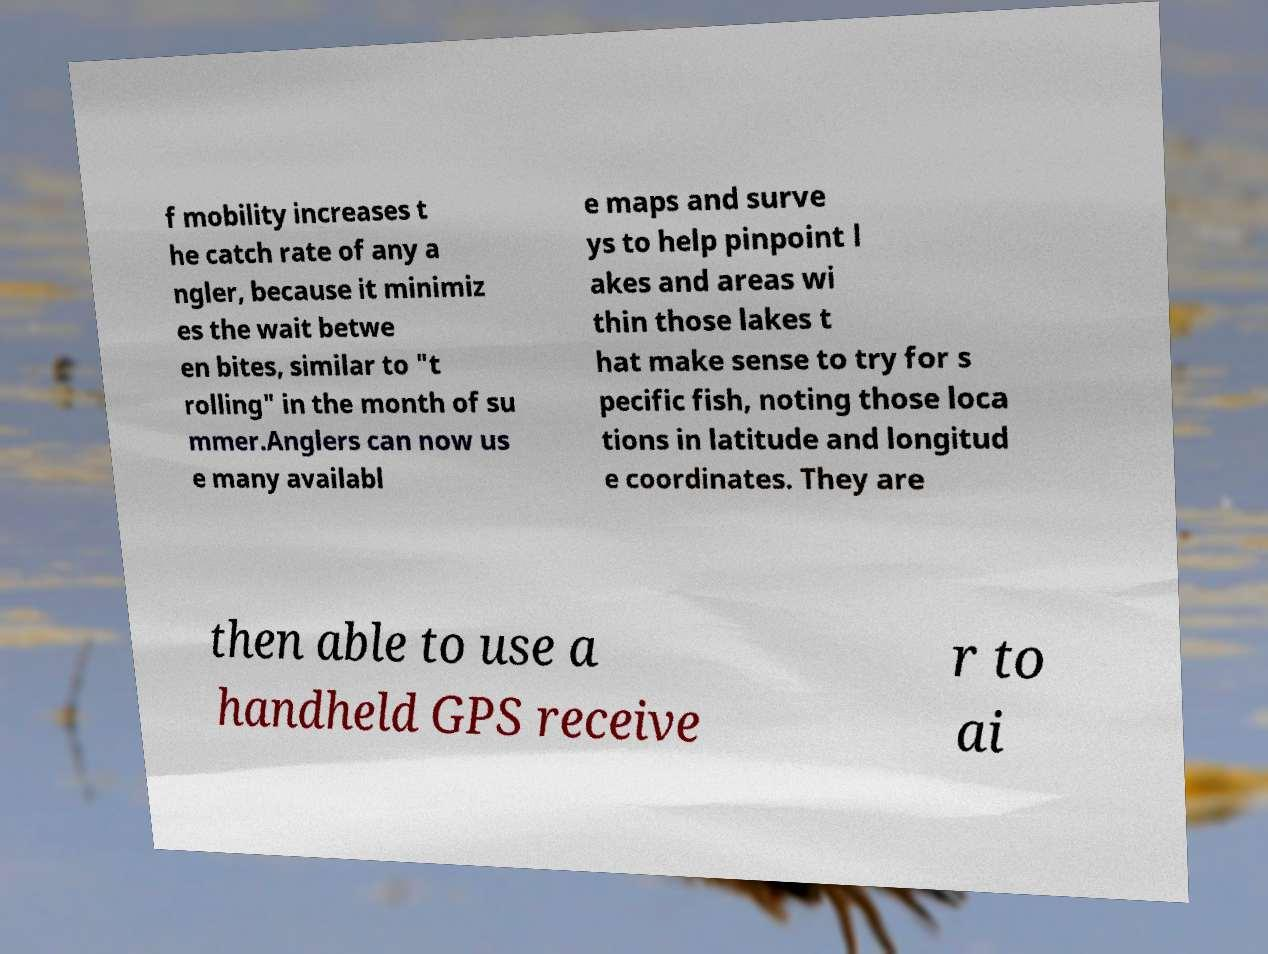There's text embedded in this image that I need extracted. Can you transcribe it verbatim? f mobility increases t he catch rate of any a ngler, because it minimiz es the wait betwe en bites, similar to "t rolling" in the month of su mmer.Anglers can now us e many availabl e maps and surve ys to help pinpoint l akes and areas wi thin those lakes t hat make sense to try for s pecific fish, noting those loca tions in latitude and longitud e coordinates. They are then able to use a handheld GPS receive r to ai 